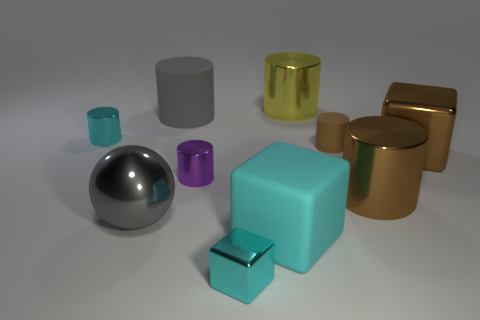How many cyan cubes must be subtracted to get 1 cyan cubes? 1 Subtract all small cyan shiny cylinders. How many cylinders are left? 5 Subtract all brown blocks. How many blocks are left? 2 Subtract 1 cubes. How many cubes are left? 2 Subtract all cylinders. How many objects are left? 4 Subtract all cyan spheres. Subtract all blue cubes. How many spheres are left? 1 Subtract all red cylinders. How many brown spheres are left? 0 Subtract all large blue matte cylinders. Subtract all balls. How many objects are left? 9 Add 7 small purple things. How many small purple things are left? 8 Add 3 brown cubes. How many brown cubes exist? 4 